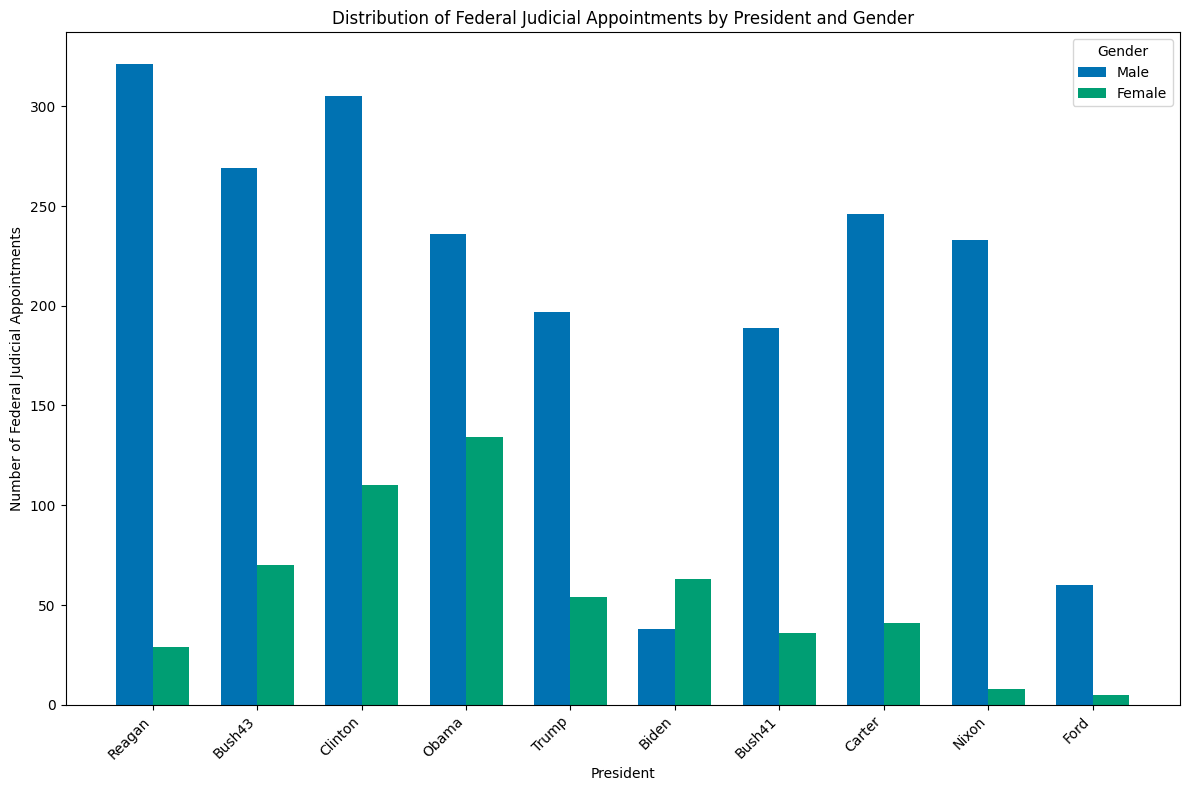Which president made the most female judicial appointments? Check the height of the bars labeled "Female" across all presidents. The tallest bar for females is under Obama.
Answer: Obama Which president has the lowest number of male judicial appointments? Check the height of the bars labeled "Male" across all presidents. Compare and find the shortest bar under Biden.
Answer: Biden How much more male than female judicial appointments did Reagan make? Find the height of Reagan's bars for "Male" and "Female". Subtract the number of "Female" from "Male" (321-29).
Answer: 292 What is the total number of judicial appointments made by Trump? Add the height of Trump's bars for both male (197) and female (54) appointments (197+54).
Answer: 251 Which president showed the largest gender disparity in judicial appointments? Calculate the absolute difference between male and female bars for each president. The largest difference is under Reagan with 292 (321-29).
Answer: Reagan Did Clinton appoint more female judges than Bush43 appointed male judges? Compare the height of Clinton's "Female" bar (110) to Bush43's "Male" bar (269).
Answer: No What is the combined number of judges appointed by Reagan, Clinton, and Obama? Add the heights of all bars for Reagan (321+29), Clinton (305+110), and Obama (236+134), then sum up (350 + 415 + 370).
Answer: 1135 Which president had the most balanced gender ratio in judicial appointments? Check for the smallest difference between male and female appointments for each president. Ford has 55 male (60-5) and 5 female, giving the smallest difference of 55.
Answer: Ford How many more total judges did Obama appoint compared to Ford? Calculate the total appointments for both Obama (236+134) and Ford (60+5), then find the difference (370 - 65).
Answer: 305 Whose female judge appointments are closest in number to Trump's female judge appointments? Compare the height of the Female bar under Trump (54) to other presidents' female bars. Bush41's female appointments (36) and Carter's (41) are closest to 54.
Answer: Carter 